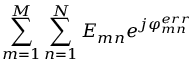Convert formula to latex. <formula><loc_0><loc_0><loc_500><loc_500>\sum _ { m = 1 } ^ { M } \sum _ { n = 1 } ^ { N } E _ { m n } e ^ { j \varphi _ { m n } ^ { e r r } }</formula> 